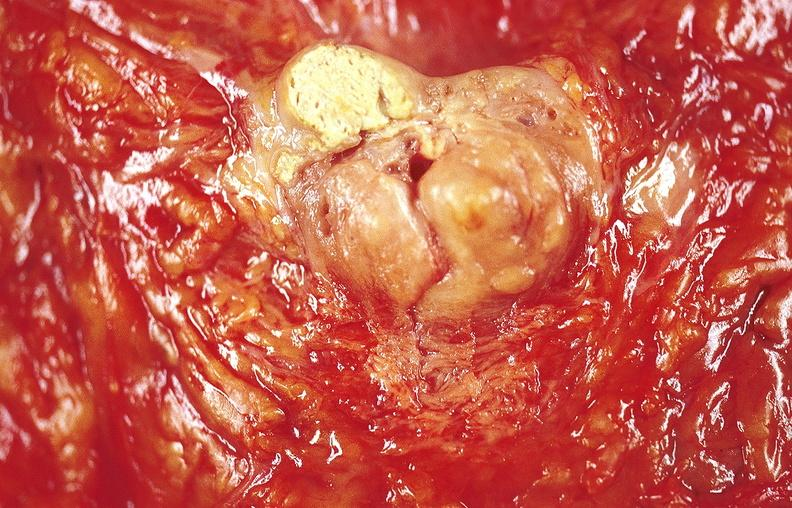what is present?
Answer the question using a single word or phrase. Gastrointestinal 